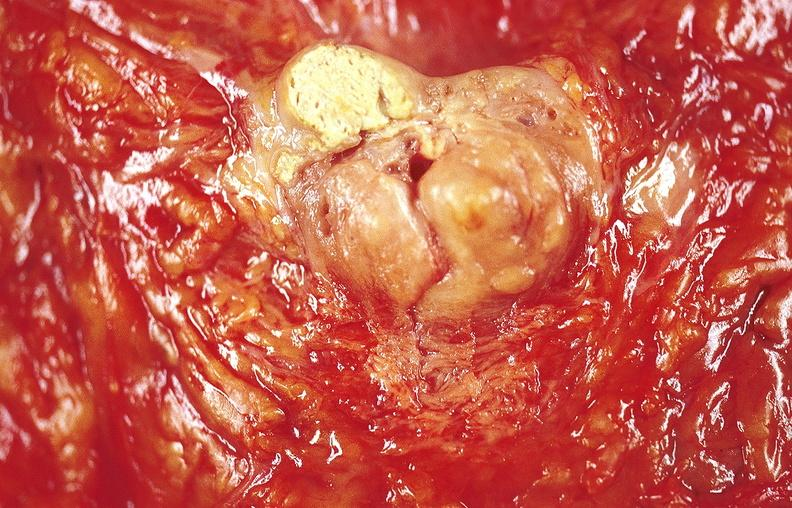what is present?
Answer the question using a single word or phrase. Gastrointestinal 